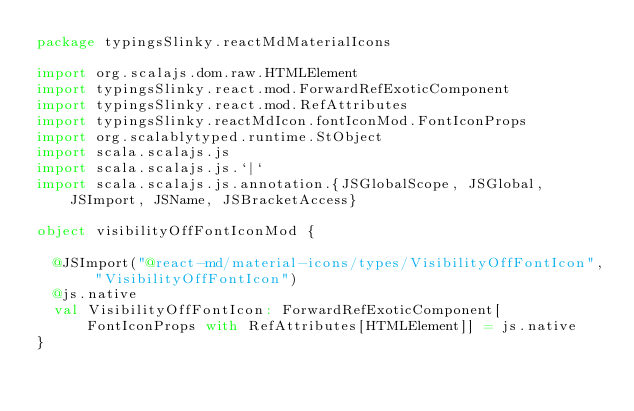<code> <loc_0><loc_0><loc_500><loc_500><_Scala_>package typingsSlinky.reactMdMaterialIcons

import org.scalajs.dom.raw.HTMLElement
import typingsSlinky.react.mod.ForwardRefExoticComponent
import typingsSlinky.react.mod.RefAttributes
import typingsSlinky.reactMdIcon.fontIconMod.FontIconProps
import org.scalablytyped.runtime.StObject
import scala.scalajs.js
import scala.scalajs.js.`|`
import scala.scalajs.js.annotation.{JSGlobalScope, JSGlobal, JSImport, JSName, JSBracketAccess}

object visibilityOffFontIconMod {
  
  @JSImport("@react-md/material-icons/types/VisibilityOffFontIcon", "VisibilityOffFontIcon")
  @js.native
  val VisibilityOffFontIcon: ForwardRefExoticComponent[FontIconProps with RefAttributes[HTMLElement]] = js.native
}
</code> 